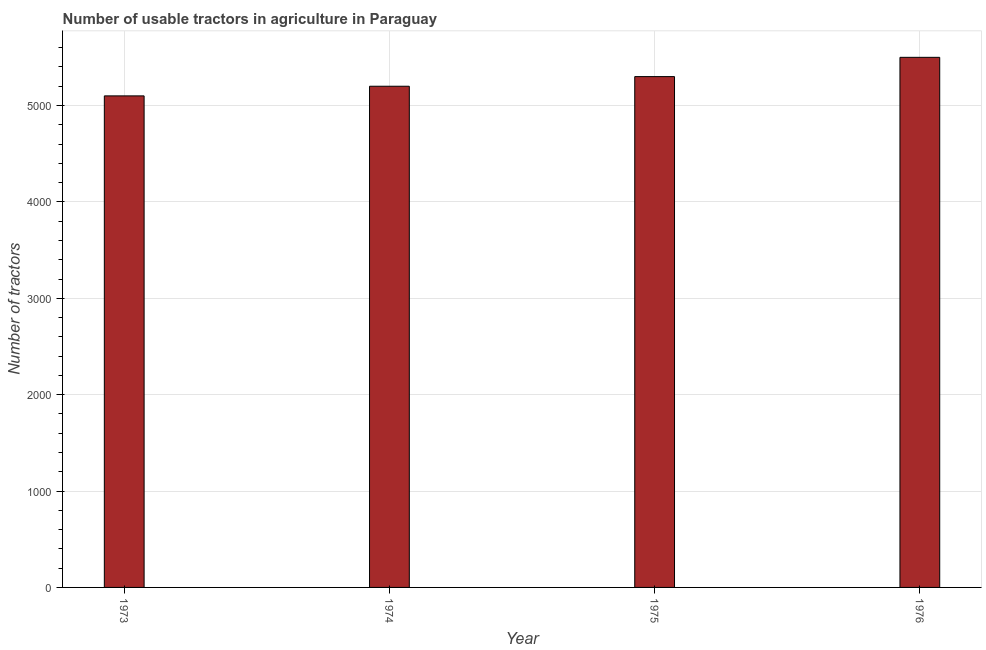Does the graph contain any zero values?
Keep it short and to the point. No. Does the graph contain grids?
Offer a terse response. Yes. What is the title of the graph?
Provide a succinct answer. Number of usable tractors in agriculture in Paraguay. What is the label or title of the X-axis?
Give a very brief answer. Year. What is the label or title of the Y-axis?
Offer a terse response. Number of tractors. What is the number of tractors in 1975?
Provide a short and direct response. 5300. Across all years, what is the maximum number of tractors?
Your answer should be compact. 5500. Across all years, what is the minimum number of tractors?
Make the answer very short. 5100. In which year was the number of tractors maximum?
Offer a terse response. 1976. What is the sum of the number of tractors?
Give a very brief answer. 2.11e+04. What is the difference between the number of tractors in 1973 and 1976?
Make the answer very short. -400. What is the average number of tractors per year?
Provide a succinct answer. 5275. What is the median number of tractors?
Your answer should be compact. 5250. Do a majority of the years between 1976 and 1974 (inclusive) have number of tractors greater than 200 ?
Your response must be concise. Yes. What is the ratio of the number of tractors in 1975 to that in 1976?
Offer a terse response. 0.96. What is the difference between the highest and the second highest number of tractors?
Give a very brief answer. 200. Is the sum of the number of tractors in 1975 and 1976 greater than the maximum number of tractors across all years?
Your answer should be very brief. Yes. What is the difference between the highest and the lowest number of tractors?
Your answer should be compact. 400. In how many years, is the number of tractors greater than the average number of tractors taken over all years?
Offer a very short reply. 2. Are all the bars in the graph horizontal?
Offer a very short reply. No. What is the difference between two consecutive major ticks on the Y-axis?
Provide a succinct answer. 1000. Are the values on the major ticks of Y-axis written in scientific E-notation?
Provide a succinct answer. No. What is the Number of tractors of 1973?
Ensure brevity in your answer.  5100. What is the Number of tractors in 1974?
Offer a very short reply. 5200. What is the Number of tractors of 1975?
Make the answer very short. 5300. What is the Number of tractors of 1976?
Keep it short and to the point. 5500. What is the difference between the Number of tractors in 1973 and 1974?
Offer a very short reply. -100. What is the difference between the Number of tractors in 1973 and 1975?
Keep it short and to the point. -200. What is the difference between the Number of tractors in 1973 and 1976?
Ensure brevity in your answer.  -400. What is the difference between the Number of tractors in 1974 and 1975?
Your response must be concise. -100. What is the difference between the Number of tractors in 1974 and 1976?
Ensure brevity in your answer.  -300. What is the difference between the Number of tractors in 1975 and 1976?
Give a very brief answer. -200. What is the ratio of the Number of tractors in 1973 to that in 1976?
Offer a terse response. 0.93. What is the ratio of the Number of tractors in 1974 to that in 1975?
Offer a very short reply. 0.98. What is the ratio of the Number of tractors in 1974 to that in 1976?
Give a very brief answer. 0.94. What is the ratio of the Number of tractors in 1975 to that in 1976?
Your response must be concise. 0.96. 